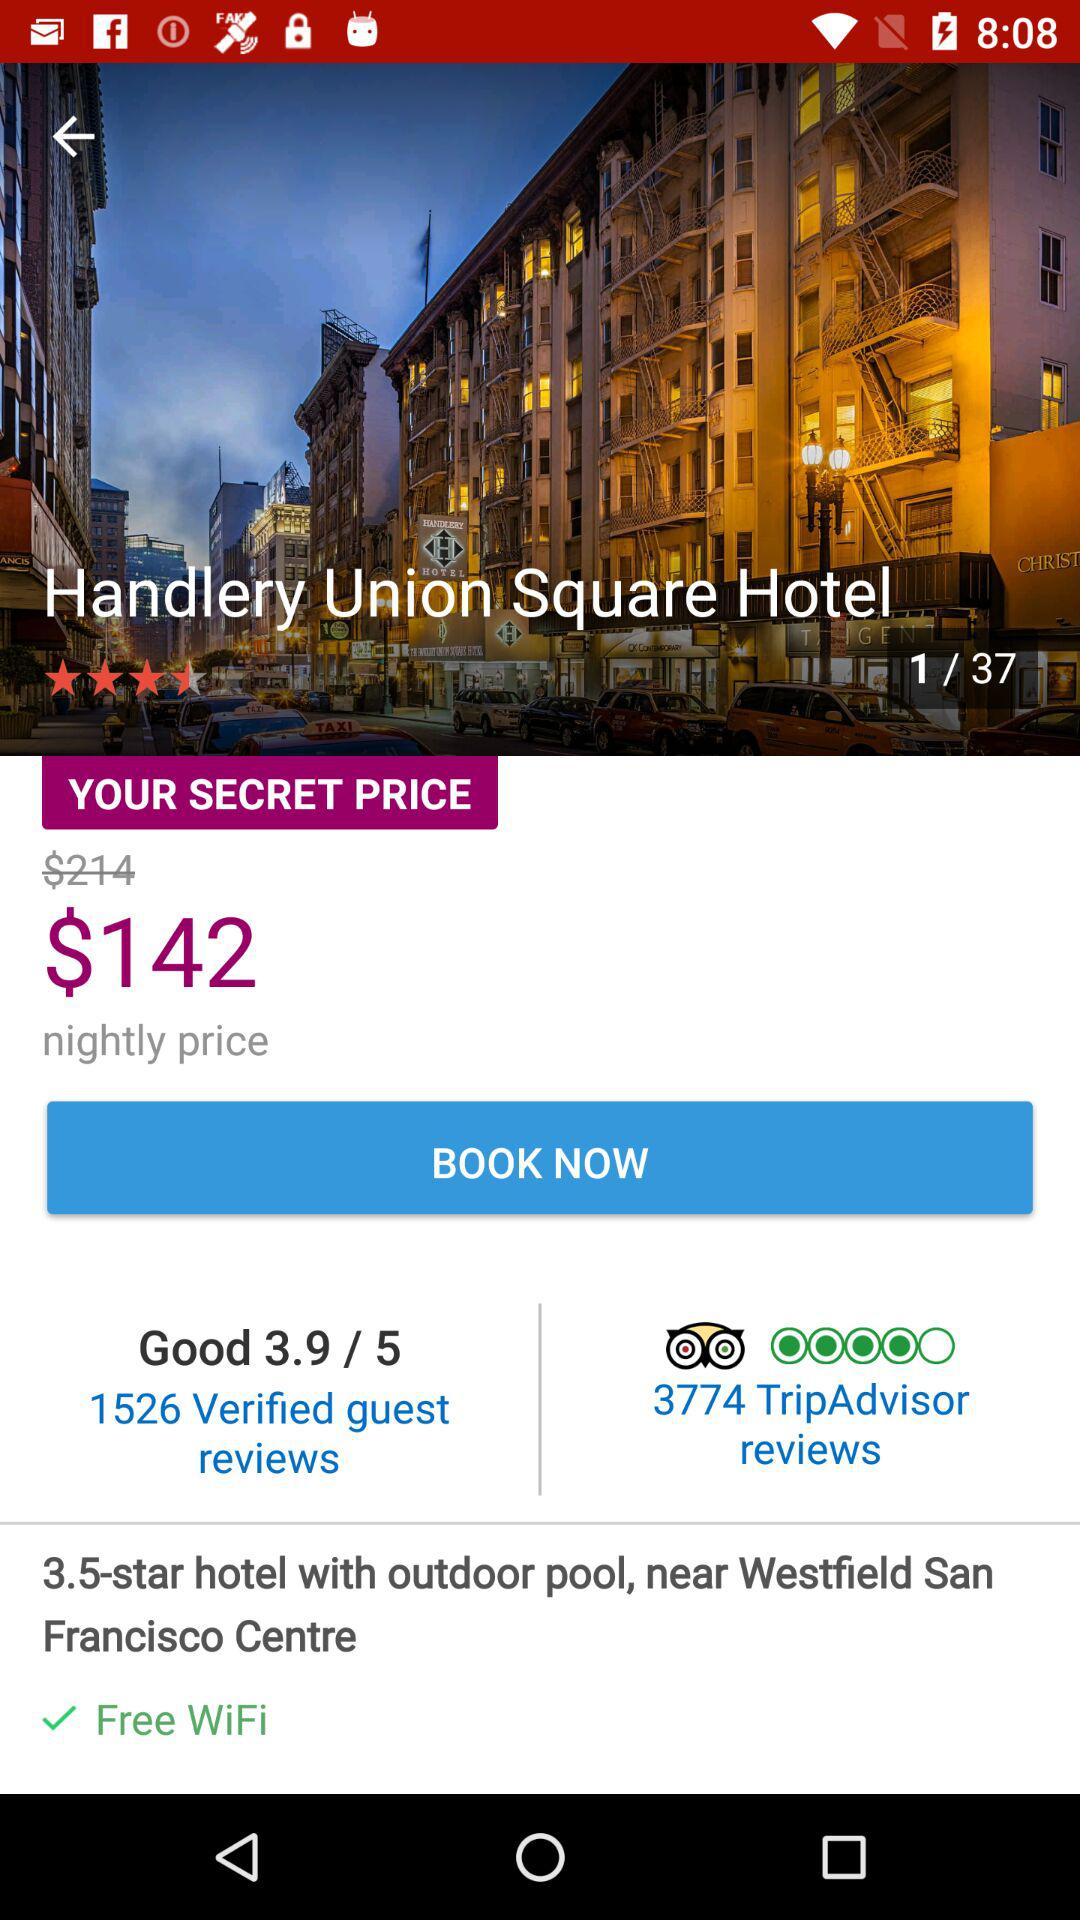What is the rating for the hotel? The rating for the hotel is 3.5 stars. 